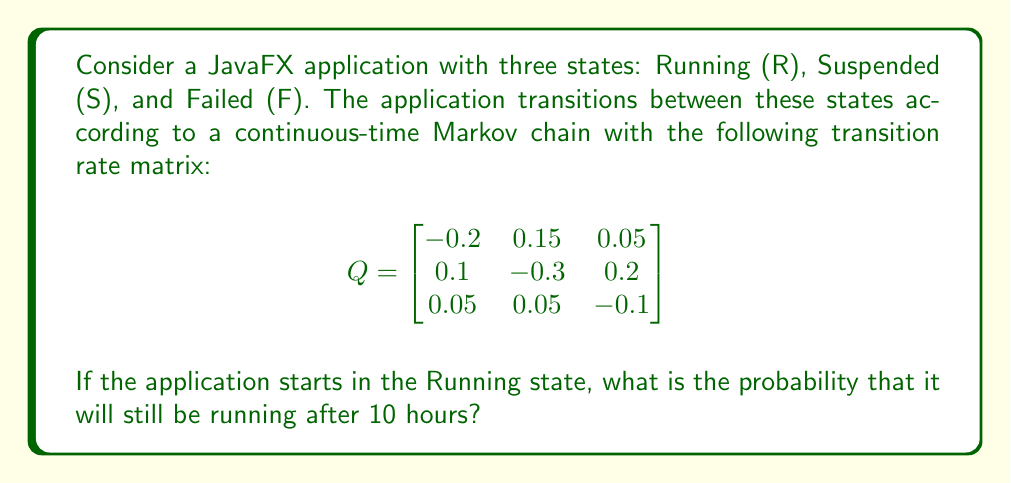Give your solution to this math problem. To solve this problem, we need to follow these steps:

1) First, we need to compute the transition probability matrix P(t) using the formula:
   $$P(t) = e^{Qt}$$
   where Q is the given transition rate matrix and t = 10 hours.

2) To calculate $e^{Qt}$, we can use the eigendecomposition method:
   $$e^{Qt} = Ve^{\Lambda t}V^{-1}$$
   where V is the matrix of eigenvectors and $\Lambda$ is the diagonal matrix of eigenvalues.

3) Calculate the eigenvalues and eigenvectors of Q:
   Eigenvalues: $\lambda_1 = 0$, $\lambda_2 \approx -0.3464$, $\lambda_3 \approx -0.2536$
   
   Eigenvectors:
   $$V \approx \begin{bmatrix}
   0.6 & -0.7746 & 0.7746 \\
   0.4 & 0.6325 & -0.6325 \\
   0.2 & 0.0141 & 0.0141
   \end{bmatrix}$$

4) Compute $e^{\Lambda t}$:
   $$e^{\Lambda t} = \begin{bmatrix}
   1 & 0 & 0 \\
   0 & e^{-0.3464 \cdot 10} & 0 \\
   0 & 0 & e^{-0.2536 \cdot 10}
   \end{bmatrix}$$

5) Calculate $P(10) = Ve^{\Lambda t}V^{-1}$:
   $$P(10) \approx \begin{bmatrix}
   0.5455 & 0.3636 & 0.0909 \\
   0.3636 & 0.4545 & 0.1818 \\
   0.1818 & 0.1818 & 0.6364
   \end{bmatrix}$$

6) The probability of the application still running after 10 hours, given it started in the Running state, is the entry in the first row and first column of P(10), which is approximately 0.5455.
Answer: 0.5455 